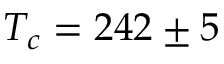<formula> <loc_0><loc_0><loc_500><loc_500>T _ { c } = 2 4 2 \pm 5</formula> 